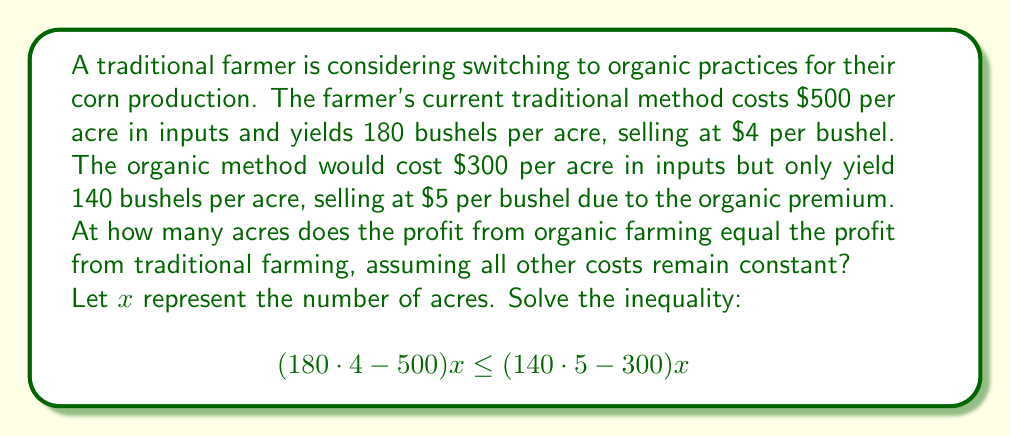Can you solve this math problem? Let's approach this step-by-step:

1) First, let's simplify the expressions inside the parentheses:

   Traditional farming: $180 \cdot 4 - 500 = 720 - 500 = 220$
   Organic farming: $140 \cdot 5 - 300 = 700 - 300 = 400$

2) Now our inequality looks like this:

   $$220x \leq 400x$$

3) To solve for the break-even point, we need to find where these are equal:

   $$220x = 400x$$

4) Subtract $220x$ from both sides:

   $$0 = 180x$$

5) Divide both sides by 180:

   $$0 = x$$

6) This means that the profits are equal when $x = 0$, or at 0 acres.

7) To determine which method is more profitable for any positive number of acres, we can check the inequality for $x > 0$:

   $$220x < 400x$$ (for $x > 0$)

This shows that for any positive number of acres, organic farming will be more profitable.
Answer: The break-even point occurs at 0 acres. For any positive number of acres, organic farming will be more profitable than traditional farming under the given conditions. 